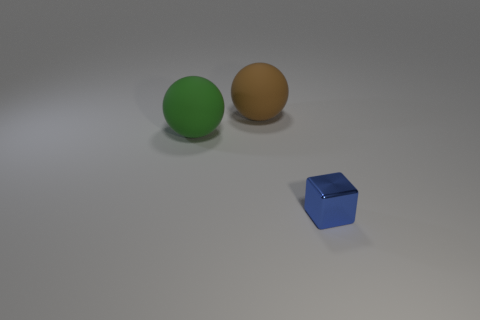Which of these objects is nearest to the camera? The green sphere is the object that appears nearest to the camera based on this perspective. 